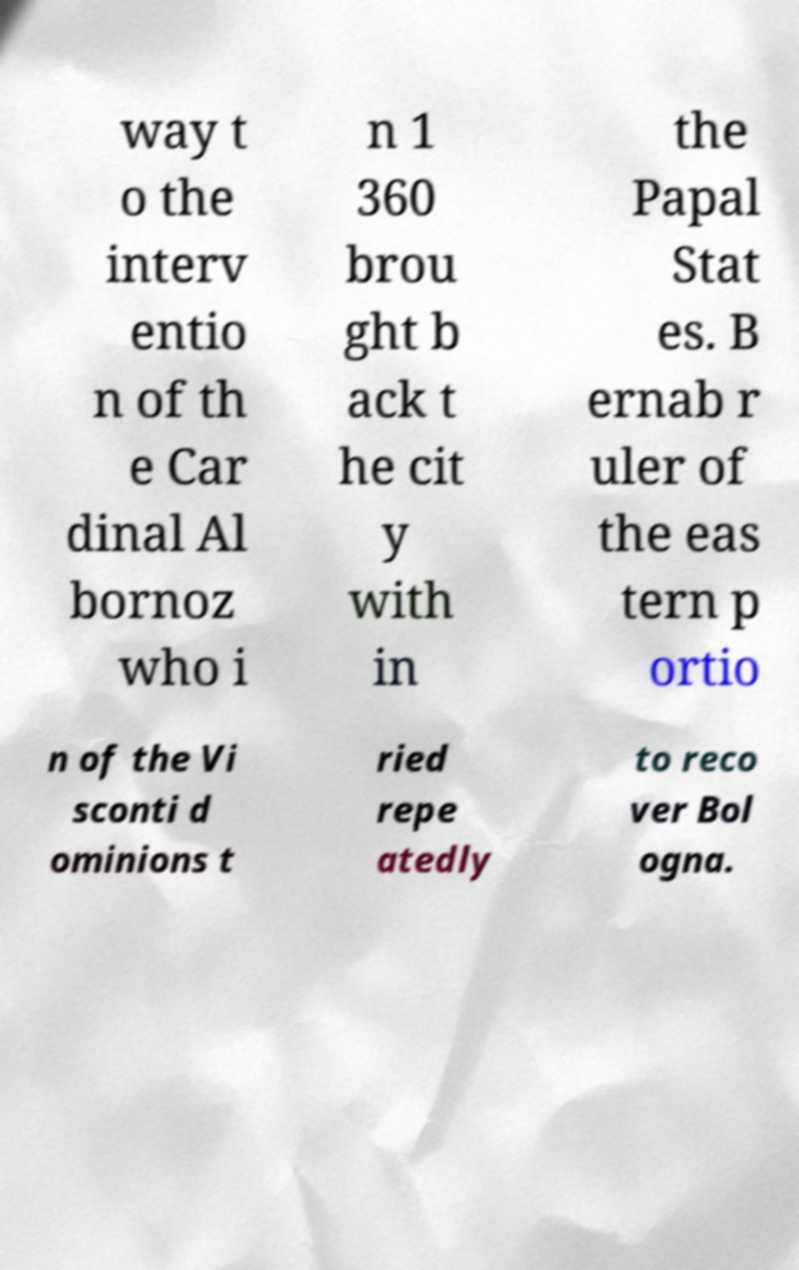Can you read and provide the text displayed in the image?This photo seems to have some interesting text. Can you extract and type it out for me? way t o the interv entio n of th e Car dinal Al bornoz who i n 1 360 brou ght b ack t he cit y with in the Papal Stat es. B ernab r uler of the eas tern p ortio n of the Vi sconti d ominions t ried repe atedly to reco ver Bol ogna. 